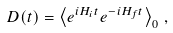Convert formula to latex. <formula><loc_0><loc_0><loc_500><loc_500>D ( t ) = \left \langle e ^ { i H _ { i } t } e ^ { - i H _ { f } t } \right \rangle _ { 0 } \, ,</formula> 